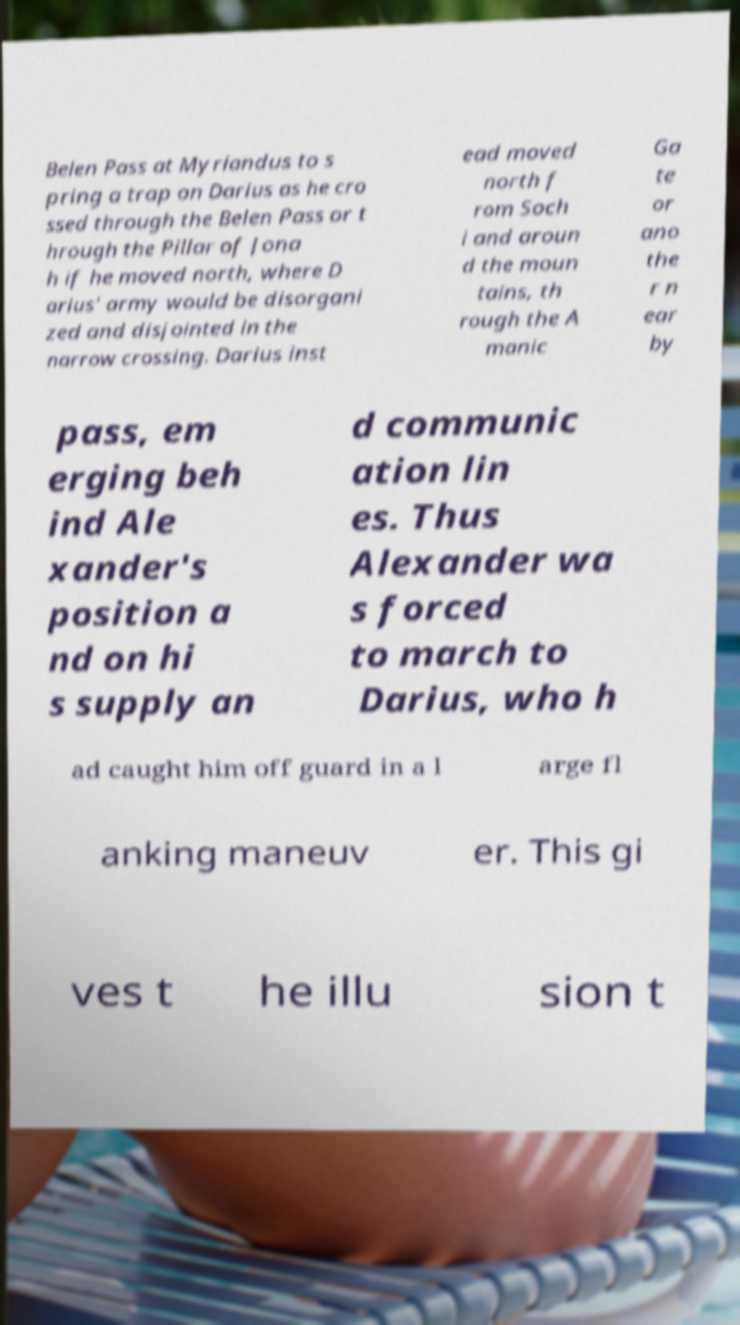Can you accurately transcribe the text from the provided image for me? Belen Pass at Myriandus to s pring a trap on Darius as he cro ssed through the Belen Pass or t hrough the Pillar of Jona h if he moved north, where D arius' army would be disorgani zed and disjointed in the narrow crossing. Darius inst ead moved north f rom Soch i and aroun d the moun tains, th rough the A manic Ga te or ano the r n ear by pass, em erging beh ind Ale xander's position a nd on hi s supply an d communic ation lin es. Thus Alexander wa s forced to march to Darius, who h ad caught him off guard in a l arge fl anking maneuv er. This gi ves t he illu sion t 